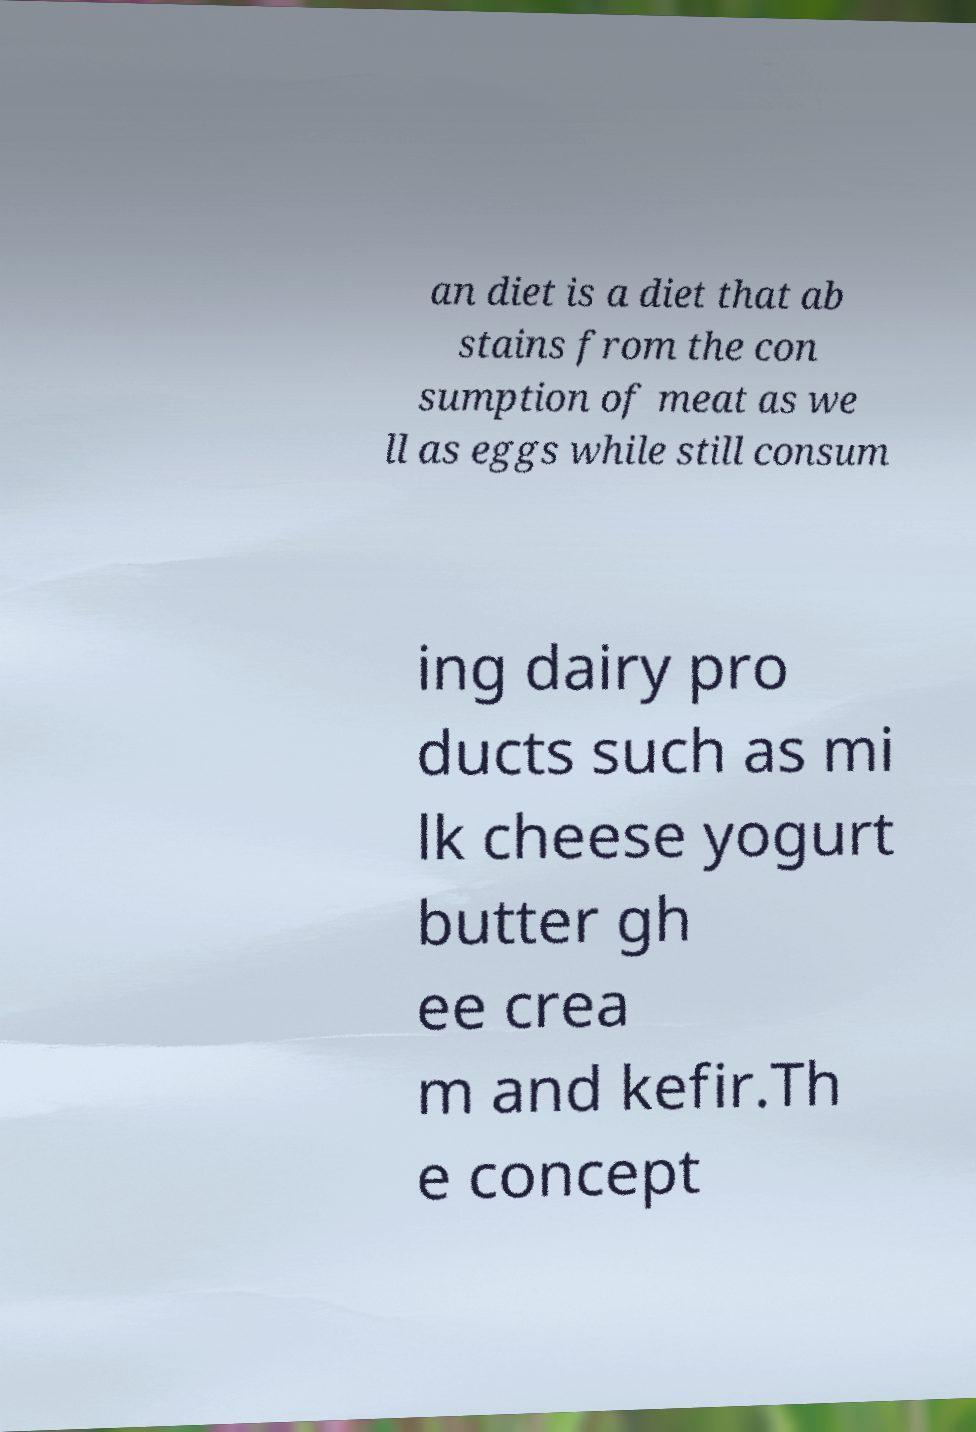There's text embedded in this image that I need extracted. Can you transcribe it verbatim? an diet is a diet that ab stains from the con sumption of meat as we ll as eggs while still consum ing dairy pro ducts such as mi lk cheese yogurt butter gh ee crea m and kefir.Th e concept 